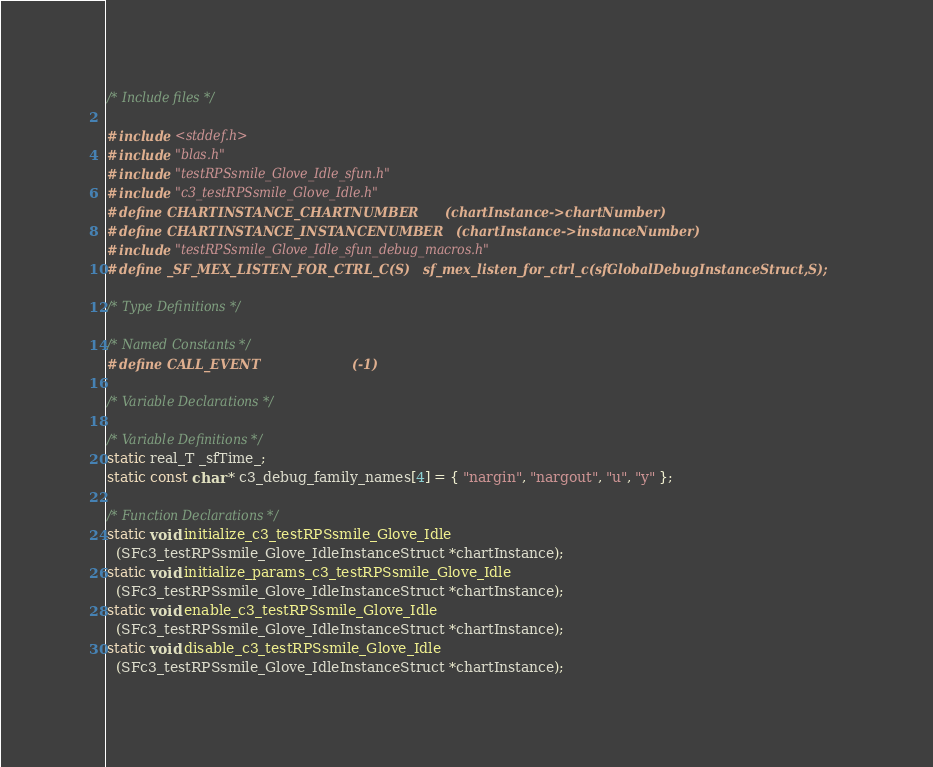Convert code to text. <code><loc_0><loc_0><loc_500><loc_500><_C_>/* Include files */

#include <stddef.h>
#include "blas.h"
#include "testRPSsmile_Glove_Idle_sfun.h"
#include "c3_testRPSsmile_Glove_Idle.h"
#define CHARTINSTANCE_CHARTNUMBER      (chartInstance->chartNumber)
#define CHARTINSTANCE_INSTANCENUMBER   (chartInstance->instanceNumber)
#include "testRPSsmile_Glove_Idle_sfun_debug_macros.h"
#define _SF_MEX_LISTEN_FOR_CTRL_C(S)   sf_mex_listen_for_ctrl_c(sfGlobalDebugInstanceStruct,S);

/* Type Definitions */

/* Named Constants */
#define CALL_EVENT                     (-1)

/* Variable Declarations */

/* Variable Definitions */
static real_T _sfTime_;
static const char * c3_debug_family_names[4] = { "nargin", "nargout", "u", "y" };

/* Function Declarations */
static void initialize_c3_testRPSsmile_Glove_Idle
  (SFc3_testRPSsmile_Glove_IdleInstanceStruct *chartInstance);
static void initialize_params_c3_testRPSsmile_Glove_Idle
  (SFc3_testRPSsmile_Glove_IdleInstanceStruct *chartInstance);
static void enable_c3_testRPSsmile_Glove_Idle
  (SFc3_testRPSsmile_Glove_IdleInstanceStruct *chartInstance);
static void disable_c3_testRPSsmile_Glove_Idle
  (SFc3_testRPSsmile_Glove_IdleInstanceStruct *chartInstance);</code> 